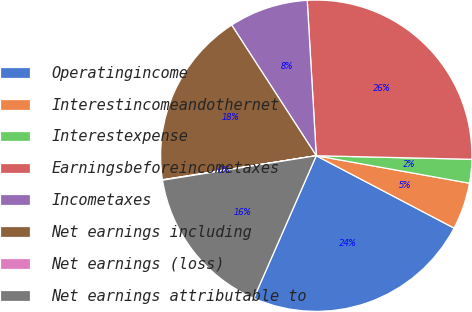Convert chart. <chart><loc_0><loc_0><loc_500><loc_500><pie_chart><fcel>Operatingincome<fcel>Interestincomeandothernet<fcel>Interestexpense<fcel>Earningsbeforeincometaxes<fcel>Incometaxes<fcel>Net earnings including<fcel>Net earnings (loss)<fcel>Net earnings attributable to<nl><fcel>23.88%<fcel>4.87%<fcel>2.46%<fcel>26.29%<fcel>8.22%<fcel>18.32%<fcel>0.05%<fcel>15.91%<nl></chart> 